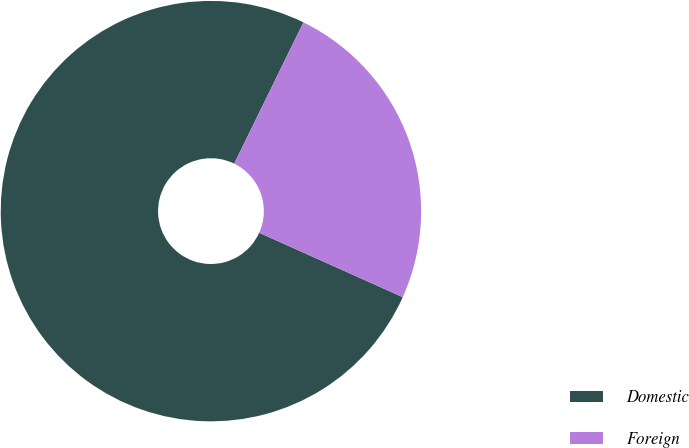Convert chart. <chart><loc_0><loc_0><loc_500><loc_500><pie_chart><fcel>Domestic<fcel>Foreign<nl><fcel>75.54%<fcel>24.46%<nl></chart> 